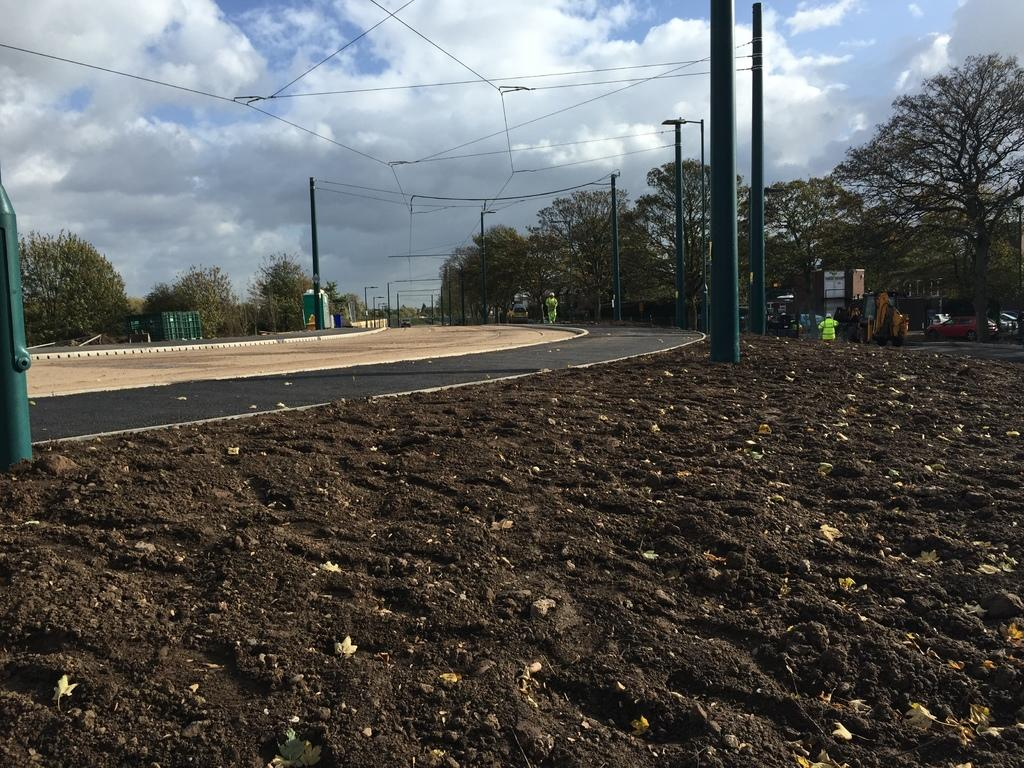What is the person in the image doing? There is a person walking on the road in the image. What structures can be seen in the image? Electric poles are visible in the image. What type of vegetation is present in the image? There are trees in the image. What else can be seen moving in the image? There are vehicles in the image. What is the color of the sky in the image? The sky is blue and white in color. How many visitors are sitting on the colorful cover in the image? There are no visitors or colorful covers present in the image. 